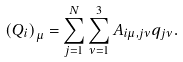Convert formula to latex. <formula><loc_0><loc_0><loc_500><loc_500>\left ( Q _ { i } \right ) _ { \mu } = \sum _ { j = 1 } ^ { N } \sum _ { \nu = 1 } ^ { 3 } A _ { i \mu , j \nu } q _ { j \nu } .</formula> 